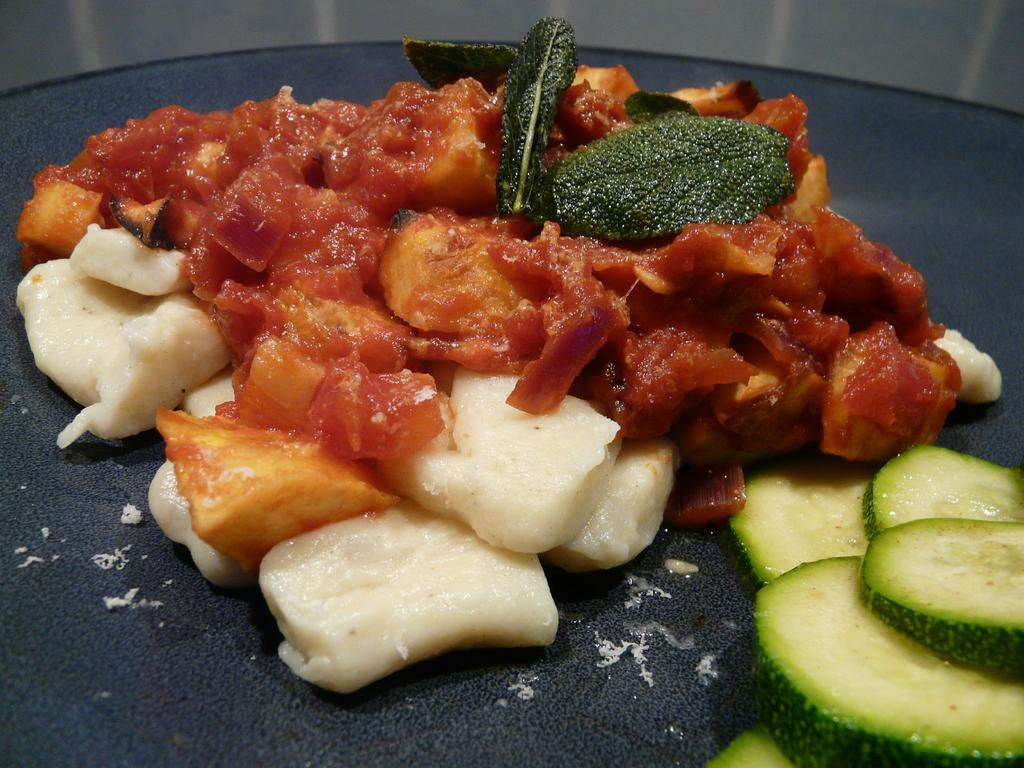What type of items can be seen in the image? There are food items in the image. What is the color of the surface on which the food items are placed? The surface is black in color. What type of leather appliance can be seen in the image? There is no leather appliance present in the image. 